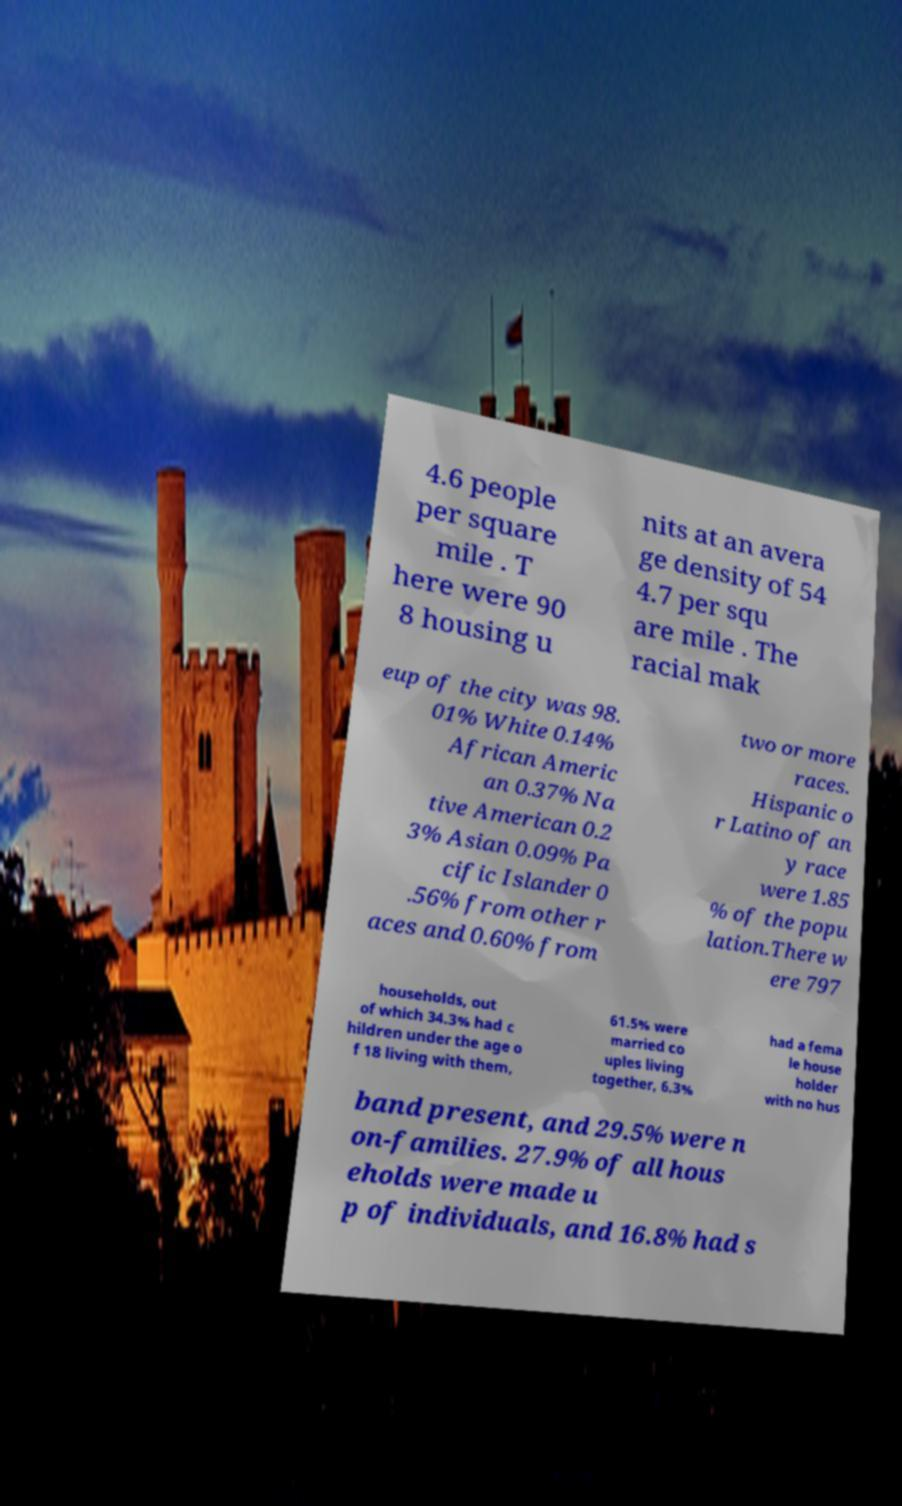Could you assist in decoding the text presented in this image and type it out clearly? 4.6 people per square mile . T here were 90 8 housing u nits at an avera ge density of 54 4.7 per squ are mile . The racial mak eup of the city was 98. 01% White 0.14% African Americ an 0.37% Na tive American 0.2 3% Asian 0.09% Pa cific Islander 0 .56% from other r aces and 0.60% from two or more races. Hispanic o r Latino of an y race were 1.85 % of the popu lation.There w ere 797 households, out of which 34.3% had c hildren under the age o f 18 living with them, 61.5% were married co uples living together, 6.3% had a fema le house holder with no hus band present, and 29.5% were n on-families. 27.9% of all hous eholds were made u p of individuals, and 16.8% had s 